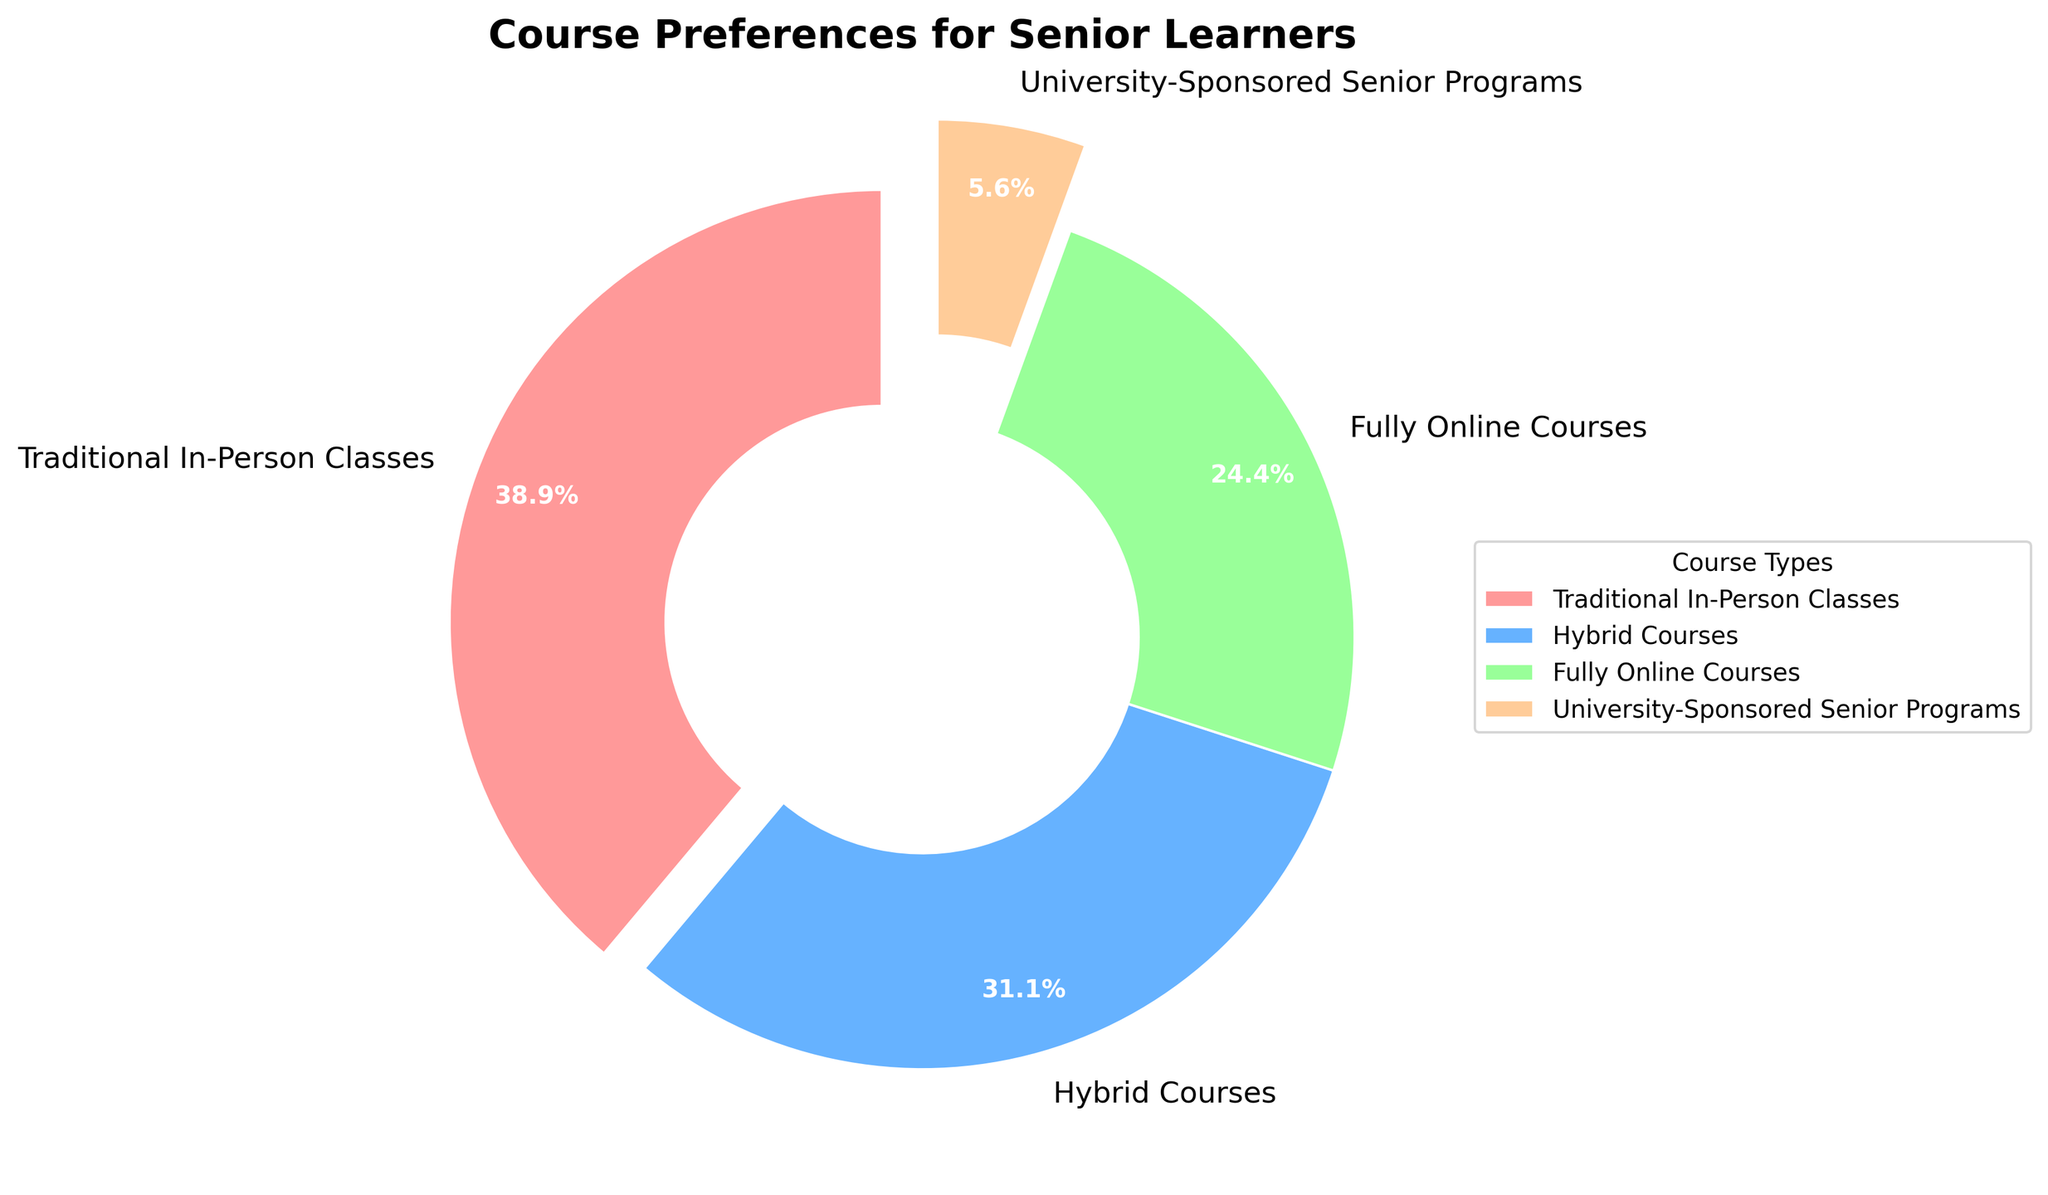Which course type is preferred the most among senior learners? By looking at the sizes of the slices in the pie chart, we can see that the largest slice represents Traditional In-Person Classes with 35%. Therefore, Traditional In-Person Classes are preferred the most.
Answer: Traditional In-Person Classes Which course type is least preferred by senior learners? The smallest slice in the pie chart represents University-Sponsored Senior Programs with 5%. Therefore, this is the least preferred course type.
Answer: University-Sponsored Senior Programs How much more popular are Traditional In-Person Classes compared to Fully Online Courses? Traditional In-Person Classes are 35% and Fully Online Courses are 22%. The difference is 35% - 22% = 13%.
Answer: 13% What proportion of seniors prefer some form of online learning (either Hybrid Courses or Fully Online Courses)? Hybrid Courses are 28% and Fully Online Courses are 22%. Together, they account for 28% + 22% = 50%.
Answer: 50% Which has a larger percentage, Hybrid Courses or Fully Online Courses, and by how much? Hybrid Courses are 28% while Fully Online Courses are 22%. The difference is 28% - 22% = 6%.
Answer: Hybrid Courses by 6% Are Hybrid Courses more or less preferred than the combination of Fully Online Courses and University-Sponsored Senior Programs? Fully Online Courses are 22% and University-Sponsored Senior Programs are 5%. Together they account for 22% + 5% = 27%. Hybrid Courses are 28%, which is higher.
Answer: More Which type of course constitutes the smallest slice of the pie chart and what is its percentage? The smallest slice of the pie chart is for University-Sponsored Senior Programs, which constitutes 5%.
Answer: University-Sponsored Senior Programs, 5% What is the combined percentage of learners who prefer either Traditional In-Person Classes or Hybrid Courses? Traditional In-Person Classes are 35% and Hybrid Courses are 28%. Combined, they account for 35% + 28% = 63%.
Answer: 63% If you were to group preferences into online (Hybrid Courses and Fully Online Courses) and in-person (Traditional In-Person Classes and University-Sponsored Senior Programs), which group has a higher percentage? Online includes Hybrid Courses (28%) and Fully Online Courses (22%), totaling 50%. In-person includes Traditional In-Person Classes (35%) and University-Sponsored Senior Programs (5%), totaling 40%. Online has a higher percentage.
Answer: Online Compare the visual size differences of the slices related to Hybrid Courses and Fully Online Courses. Do they appear significantly different? By observing the pie chart, the slice for Hybrid Courses appears slightly larger than the slice for Fully Online Courses, which corresponds to a 6% difference (28% vs 22%). They do not appear significantly different but the difference is noticeable.
Answer: Slightly larger 